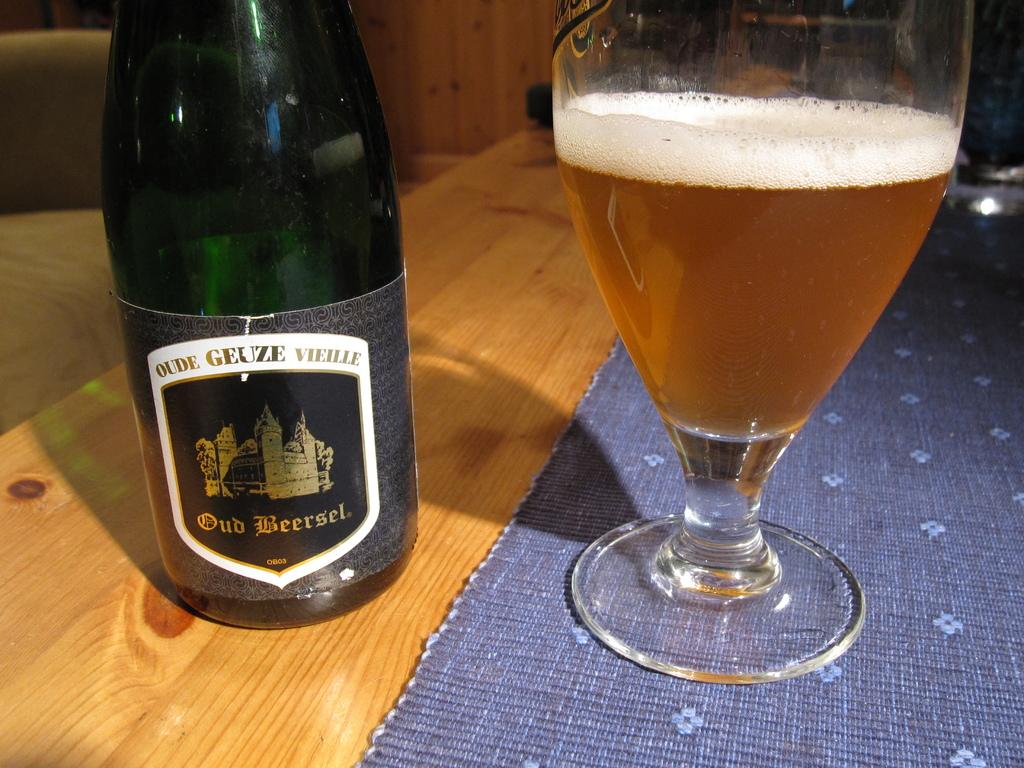<image>
Present a compact description of the photo's key features. A glass bottle of Oud Beersel next to a glass 